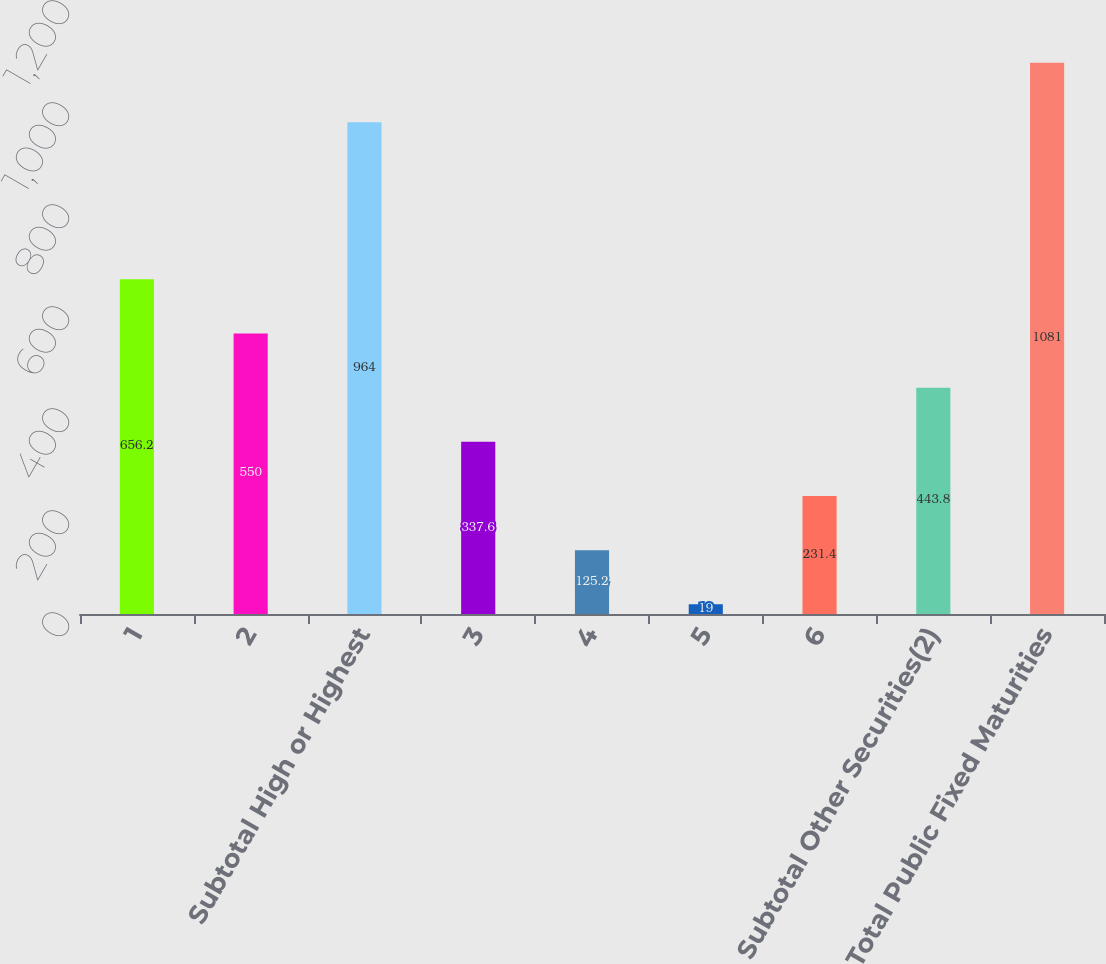Convert chart to OTSL. <chart><loc_0><loc_0><loc_500><loc_500><bar_chart><fcel>1<fcel>2<fcel>Subtotal High or Highest<fcel>3<fcel>4<fcel>5<fcel>6<fcel>Subtotal Other Securities(2)<fcel>Total Public Fixed Maturities<nl><fcel>656.2<fcel>550<fcel>964<fcel>337.6<fcel>125.2<fcel>19<fcel>231.4<fcel>443.8<fcel>1081<nl></chart> 